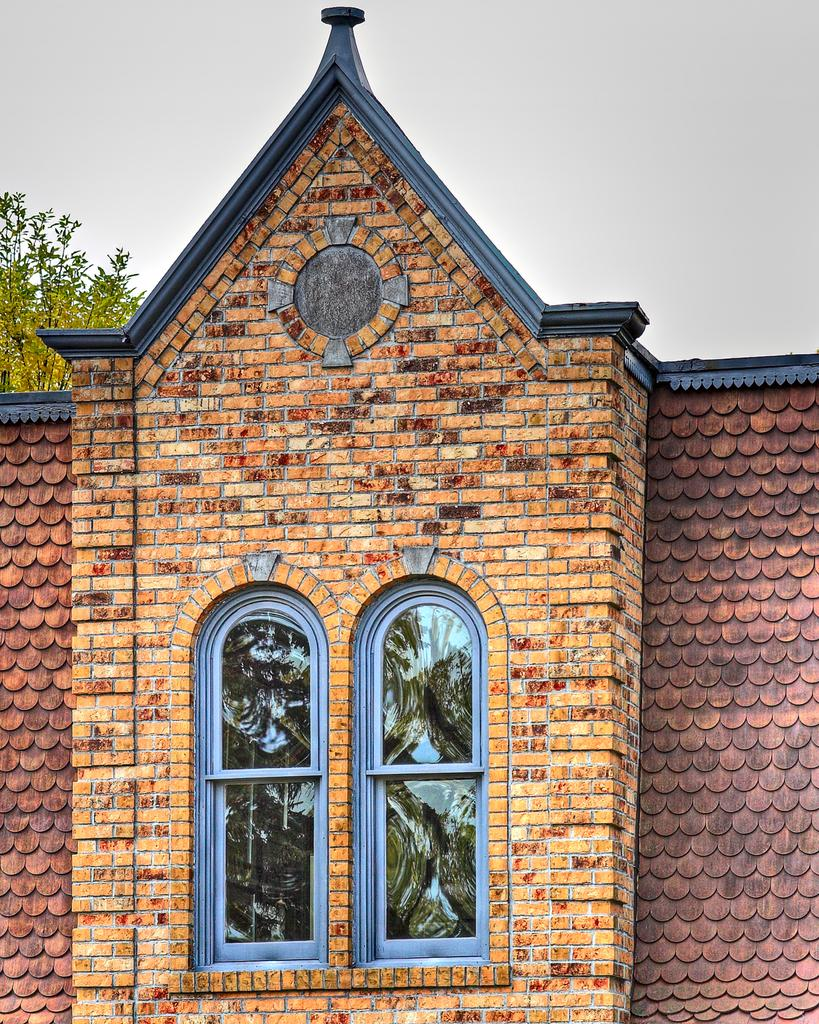What type of structure is visible in the image? There is a house in the image. What feature can be seen on the house? There are windows in the image. What type of vegetation is present in the image? There is a tree in the image. What is visible in the background of the image? The sky is visible in the image. What page number is the tree located on in the image? There are no pages or numbers present in the image; it is a photograph of a house, tree, and sky. 